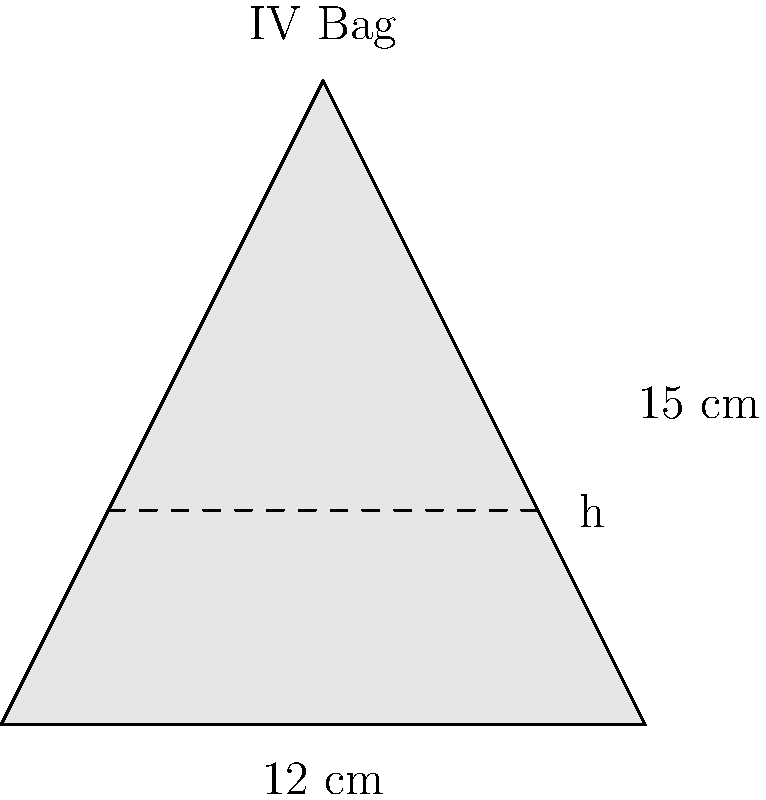An IV bag is shaped like a cone with a base diameter of 12 cm and a height of 15 cm. If the medication needs to be administered at a rate of 2 mL/min, how long will it take to administer 100 mL of medication? Assume the fluid level in the bag forms a smaller cone similar to the bag itself. To solve this problem, we need to follow these steps:

1) First, calculate the volume of the entire cone (IV bag):
   $$V_{total} = \frac{1}{3}\pi r^2 h$$
   where $r$ is the radius of the base (6 cm) and $h$ is the height (15 cm).
   $$V_{total} = \frac{1}{3}\pi (6 \text{ cm})^2 (15 \text{ cm}) = 565.49 \text{ cm}^3$$

2) Convert 100 mL to cm³:
   $$100 \text{ mL} = 100 \text{ cm}^3$$

3) Calculate the volume of the cone after administering 100 mL:
   $$V_{remaining} = 565.49 \text{ cm}^3 - 100 \text{ cm}^3 = 465.49 \text{ cm}^3$$

4) Use the similarity of cones to find the height of the remaining fluid:
   $$\frac{V_{remaining}}{V_{total}} = \left(\frac{h_{remaining}}{h_{total}}\right)^3$$
   
   $$\frac{465.49}{565.49} = \left(\frac{h_{remaining}}{15}\right)^3$$
   
   $$h_{remaining} = 15 \sqrt[3]{\frac{465.49}{565.49}} = 14.06 \text{ cm}$$

5) Calculate the change in height:
   $$\Delta h = 15 \text{ cm} - 14.06 \text{ cm} = 0.94 \text{ cm}$$

6) Calculate the time needed to administer 100 mL:
   $$\text{Time} = \frac{100 \text{ mL}}{2 \text{ mL/min}} = 50 \text{ minutes}$$

Therefore, it will take 50 minutes to administer 100 mL of medication.
Answer: 50 minutes 